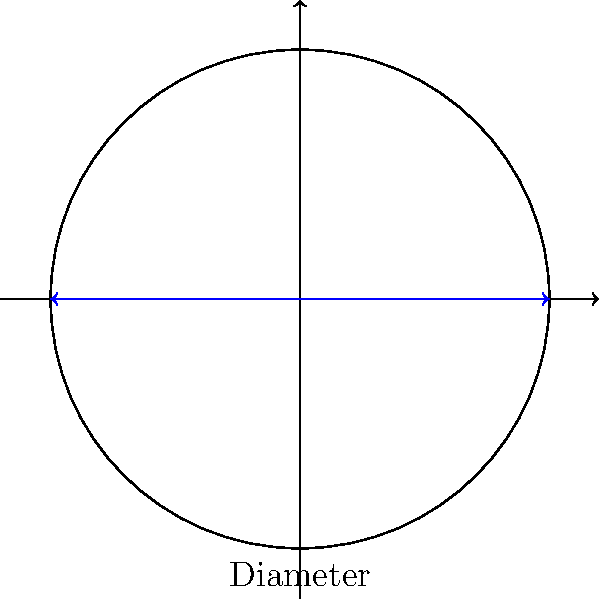As an independent musician, you're considering pressing your latest track on vinyl. The pressing plant offers a 12-inch diameter record. Assuming the record is a perfect circle, calculate its area. How much space do you really have for your music, and is it worth the hype? (Use $\pi \approx 3.14$ for calculations) Let's approach this step-by-step:

1) The diameter of the record is 12 inches. We need to find the radius.
   Radius = Diameter ÷ 2
   $r = 12 \div 2 = 6$ inches

2) The formula for the area of a circle is $A = \pi r^2$

3) Substituting our values:
   $A = 3.14 \times 6^2$

4) Simplify:
   $A = 3.14 \times 36 = 113.04$ square inches

5) Round to two decimal places:
   $A \approx 113.04$ square inches

So, the area of your vinyl record would be approximately 113.04 square inches. 

Is it worth the hype? Well, that depends on your perspective. While 113.04 square inches might seem like a lot, remember that this includes the label area and the run-out groove. The actual playable area is less. Plus, consider the limitations of analog sound reproduction compared to digital. But then again, some argue that vinyl has a warmer, more authentic sound. It's up to you to decide if the nostalgia and perceived authenticity outweigh the practical limitations.
Answer: $113.04$ square inches 